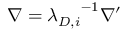Convert formula to latex. <formula><loc_0><loc_0><loc_500><loc_500>\nabla = { \lambda _ { D , i } } ^ { - 1 } { \nabla ^ { \prime } }</formula> 